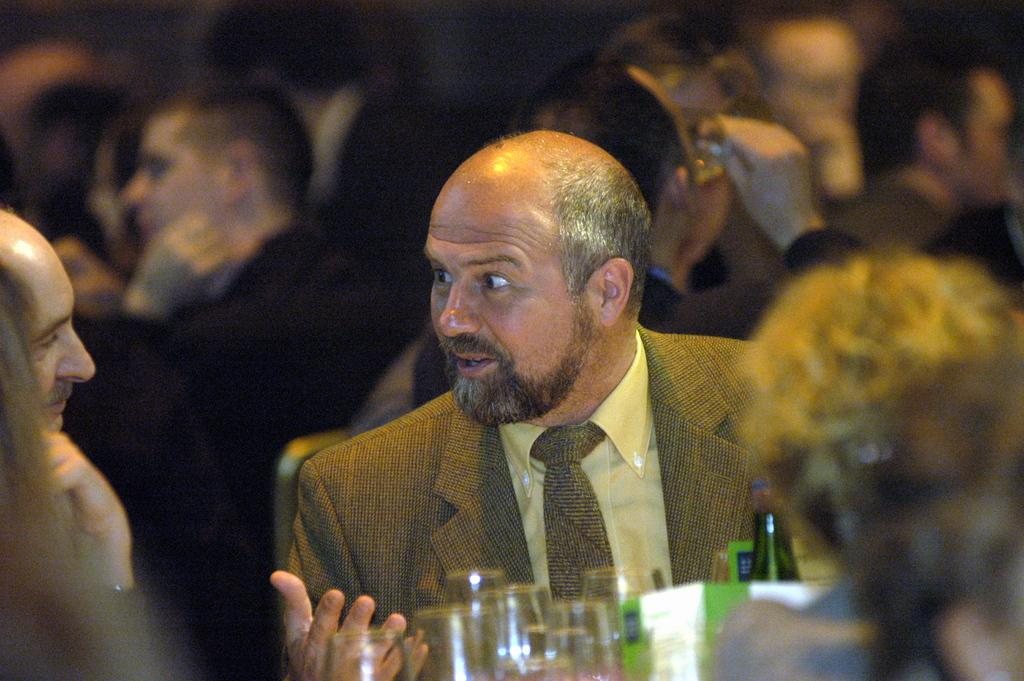Who or what can be seen in the image? There are people in the image. What objects are present in the image along with the people? There are glasses in the image. What type of muscle is being flexed by the people in the image? There is no indication of any muscles being flexed in the image; the people are simply present. 